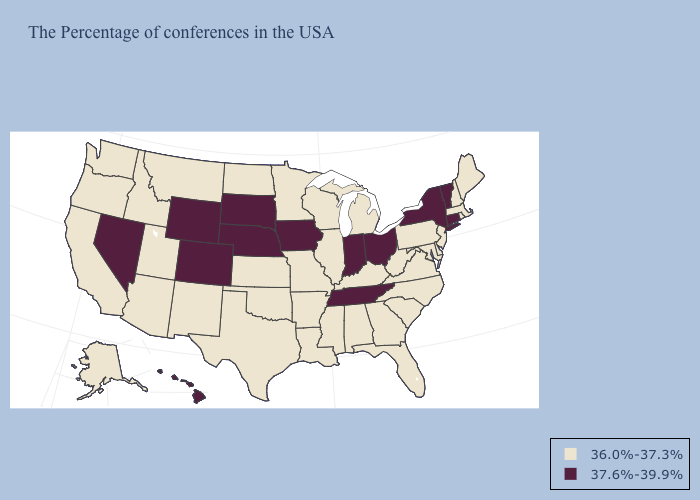What is the highest value in the South ?
Answer briefly. 37.6%-39.9%. Does the first symbol in the legend represent the smallest category?
Answer briefly. Yes. Is the legend a continuous bar?
Quick response, please. No. Does California have a lower value than Alabama?
Keep it brief. No. What is the highest value in states that border Alabama?
Give a very brief answer. 37.6%-39.9%. Name the states that have a value in the range 36.0%-37.3%?
Answer briefly. Maine, Massachusetts, Rhode Island, New Hampshire, New Jersey, Delaware, Maryland, Pennsylvania, Virginia, North Carolina, South Carolina, West Virginia, Florida, Georgia, Michigan, Kentucky, Alabama, Wisconsin, Illinois, Mississippi, Louisiana, Missouri, Arkansas, Minnesota, Kansas, Oklahoma, Texas, North Dakota, New Mexico, Utah, Montana, Arizona, Idaho, California, Washington, Oregon, Alaska. Does the first symbol in the legend represent the smallest category?
Give a very brief answer. Yes. What is the value of Minnesota?
Give a very brief answer. 36.0%-37.3%. Among the states that border New Jersey , which have the highest value?
Give a very brief answer. New York. Does Connecticut have the highest value in the USA?
Short answer required. Yes. Which states have the lowest value in the USA?
Quick response, please. Maine, Massachusetts, Rhode Island, New Hampshire, New Jersey, Delaware, Maryland, Pennsylvania, Virginia, North Carolina, South Carolina, West Virginia, Florida, Georgia, Michigan, Kentucky, Alabama, Wisconsin, Illinois, Mississippi, Louisiana, Missouri, Arkansas, Minnesota, Kansas, Oklahoma, Texas, North Dakota, New Mexico, Utah, Montana, Arizona, Idaho, California, Washington, Oregon, Alaska. What is the value of Kentucky?
Answer briefly. 36.0%-37.3%. Which states have the lowest value in the MidWest?
Quick response, please. Michigan, Wisconsin, Illinois, Missouri, Minnesota, Kansas, North Dakota. What is the highest value in the MidWest ?
Quick response, please. 37.6%-39.9%. 